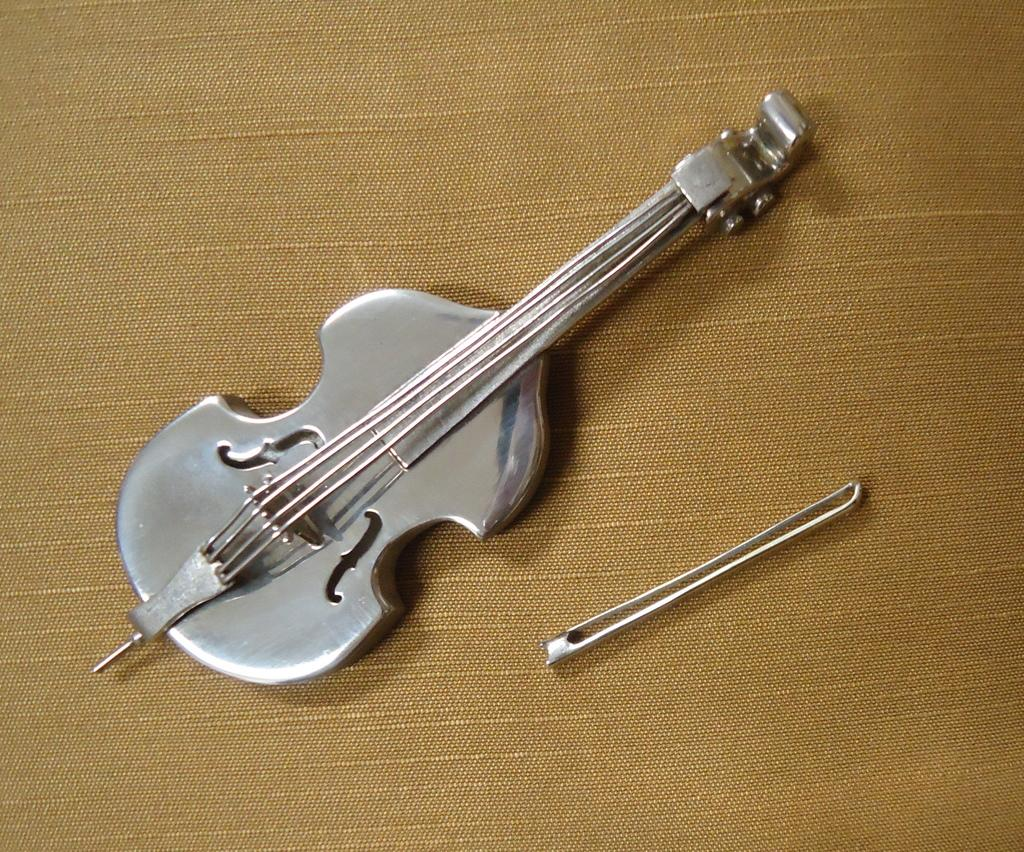What musical instrument is present in the image? There is a fiddle in the image. What is the fiddle placed on? The fiddle is on a cloth. What type of cracker is being used to play the fiddle in the image? There is no cracker present in the image, and the fiddle is not being played with a cracker. 